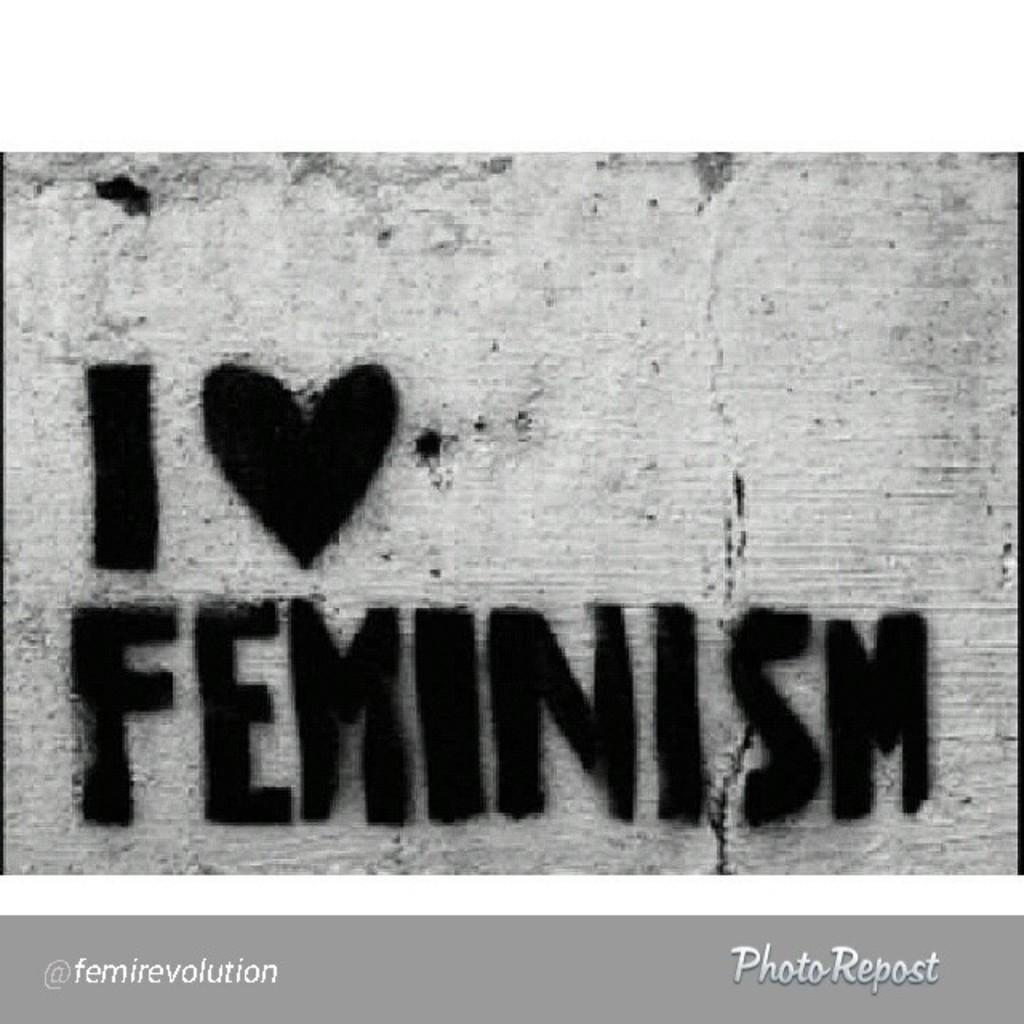<image>
Offer a succinct explanation of the picture presented. Graffiti of I love Feminism on a concrete wall. 